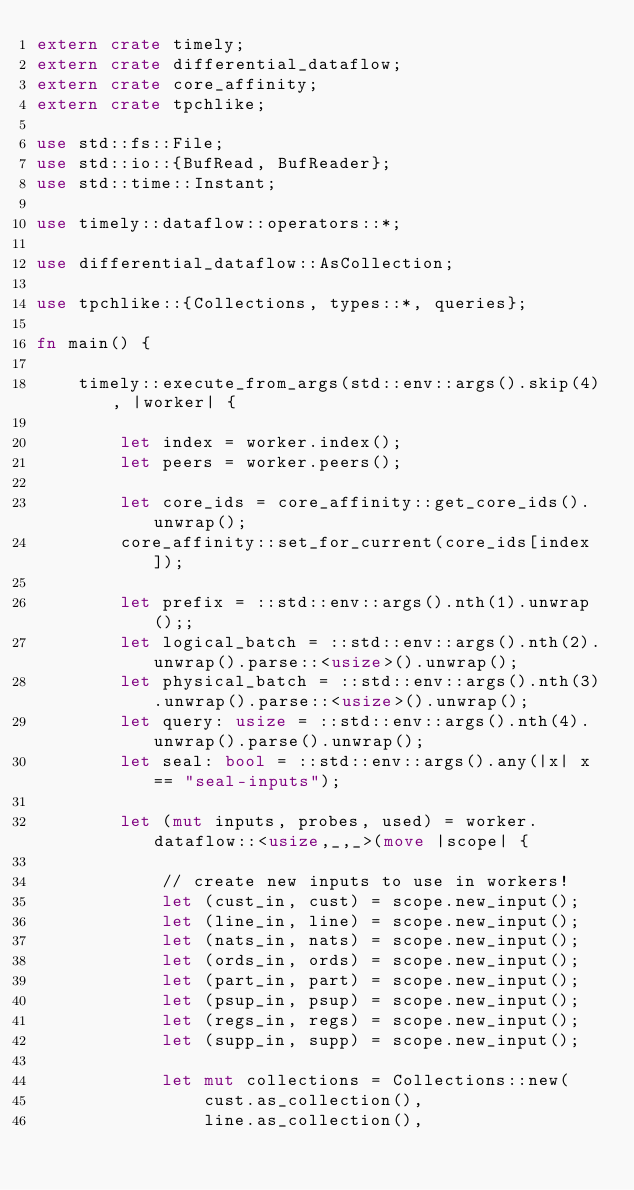<code> <loc_0><loc_0><loc_500><loc_500><_Rust_>extern crate timely;
extern crate differential_dataflow;
extern crate core_affinity;
extern crate tpchlike;

use std::fs::File;
use std::io::{BufRead, BufReader};
use std::time::Instant;

use timely::dataflow::operators::*;

use differential_dataflow::AsCollection;

use tpchlike::{Collections, types::*, queries};

fn main() {

    timely::execute_from_args(std::env::args().skip(4), |worker| {

        let index = worker.index();
        let peers = worker.peers();

        let core_ids = core_affinity::get_core_ids().unwrap();
        core_affinity::set_for_current(core_ids[index]);

        let prefix = ::std::env::args().nth(1).unwrap();;
        let logical_batch = ::std::env::args().nth(2).unwrap().parse::<usize>().unwrap();
        let physical_batch = ::std::env::args().nth(3).unwrap().parse::<usize>().unwrap();
        let query: usize = ::std::env::args().nth(4).unwrap().parse().unwrap();
        let seal: bool = ::std::env::args().any(|x| x == "seal-inputs");

        let (mut inputs, probes, used) = worker.dataflow::<usize,_,_>(move |scope| {

            // create new inputs to use in workers!
            let (cust_in, cust) = scope.new_input();
            let (line_in, line) = scope.new_input();
            let (nats_in, nats) = scope.new_input();
            let (ords_in, ords) = scope.new_input();
            let (part_in, part) = scope.new_input();
            let (psup_in, psup) = scope.new_input();
            let (regs_in, regs) = scope.new_input();
            let (supp_in, supp) = scope.new_input();

            let mut collections = Collections::new(
                cust.as_collection(),
                line.as_collection(),</code> 